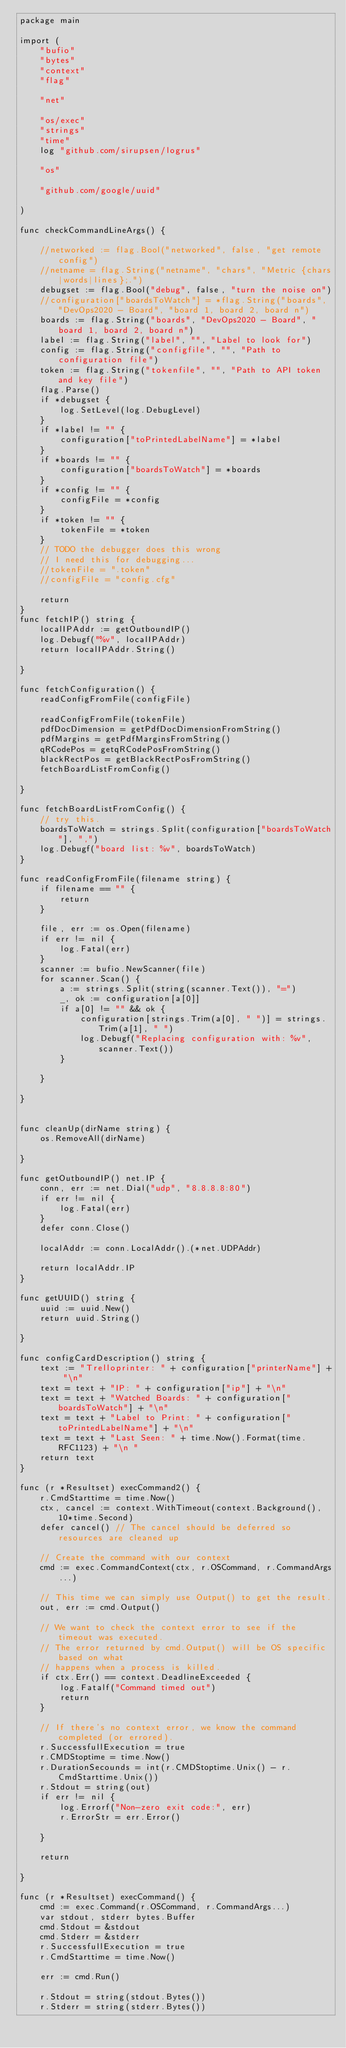<code> <loc_0><loc_0><loc_500><loc_500><_Go_>package main

import (
	"bufio"
	"bytes"
	"context"
	"flag"
	
	"net"

	"os/exec"
	"strings"
	"time"
	log "github.com/sirupsen/logrus"

	"os"

	"github.com/google/uuid"

)

func checkCommandLineArgs() {

	//networked := flag.Bool("networked", false, "get remote config")
	//netname = flag.String("netname", "chars", "Metric {chars|words|lines};.")
	debugset := flag.Bool("debug", false, "turn the noise on")
	//configuration["boardsToWatch"] = *flag.String("boards", "DevOps2020 - Board", "board 1, board 2, board n")
	boards := flag.String("boards", "DevOps2020 - Board", "board 1, board 2, board n")
	label := flag.String("label", "", "Label to look for")
	config := flag.String("configfile", "", "Path to configuration file")
	token := flag.String("tokenfile", "", "Path to API token and key file")
	flag.Parse()
	if *debugset {
		log.SetLevel(log.DebugLevel)
	}
	if *label != "" {
		configuration["toPrintedLabelName"] = *label
	}
	if *boards != "" {
		configuration["boardsToWatch"] = *boards
	}
	if *config != "" {
		configFile = *config
	}
	if *token != "" {
		tokenFile = *token
	}
	// TODO the debugger does this wrong
	// I need this for debugging...
	//tokenFile = ".token"
	//configFile = "config.cfg"

	return
}
func fetchIP() string {
	localIPAddr := getOutboundIP()
	log.Debugf("%v", localIPAddr)
	return localIPAddr.String()

}

func fetchConfiguration() {
	readConfigFromFile(configFile)

	readConfigFromFile(tokenFile)
	pdfDocDimension = getPdfDocDimensionFromString()
	pdfMargins = getPdfMarginsFromString()
	qRCodePos = getqRCodePosFromString()
	blackRectPos = getBlackRectPosFromString()
	fetchBoardListFromConfig()

}

func fetchBoardListFromConfig() {
	// try this.
	boardsToWatch = strings.Split(configuration["boardsToWatch"], ",")
	log.Debugf("board list: %v", boardsToWatch)
}

func readConfigFromFile(filename string) {
	if filename == "" {
		return
	}

	file, err := os.Open(filename)
	if err != nil {
		log.Fatal(err)
	}
	scanner := bufio.NewScanner(file)
	for scanner.Scan() {
		a := strings.Split(string(scanner.Text()), "=")
		_, ok := configuration[a[0]]
		if a[0] != "" && ok {
			configuration[strings.Trim(a[0], " ")] = strings.Trim(a[1], " ")
			log.Debugf("Replacing configuration with: %v", scanner.Text())
		}

	}

}


func cleanUp(dirName string) {
	os.RemoveAll(dirName)

}

func getOutboundIP() net.IP {
	conn, err := net.Dial("udp", "8.8.8.8:80")
	if err != nil {
		log.Fatal(err)
	}
	defer conn.Close()

	localAddr := conn.LocalAddr().(*net.UDPAddr)

	return localAddr.IP
}

func getUUID() string {
	uuid := uuid.New()
	return uuid.String()

}

func configCardDescription() string {
	text := "Trelloprinter: " + configuration["printerName"] + "\n"
	text = text + "IP: " + configuration["ip"] + "\n"
	text = text + "Watched Boards: " + configuration["boardsToWatch"] + "\n"
	text = text + "Label to Print: " + configuration["toPrintedLabelName"] + "\n"
	text = text + "Last Seen: " + time.Now().Format(time.RFC1123) + "\n "
	return text
}

func (r *Resultset) execCommand2() {
	r.CmdStarttime = time.Now()
	ctx, cancel := context.WithTimeout(context.Background(), 10*time.Second)
	defer cancel() // The cancel should be deferred so resources are cleaned up

	// Create the command with our context
	cmd := exec.CommandContext(ctx, r.OSCommand, r.CommandArgs...)

	// This time we can simply use Output() to get the result.
	out, err := cmd.Output()

	// We want to check the context error to see if the timeout was executed.
	// The error returned by cmd.Output() will be OS specific based on what
	// happens when a process is killed.
	if ctx.Err() == context.DeadlineExceeded {
		log.Fatalf("Command timed out")
		return
	}

	// If there's no context error, we know the command completed (or errored).
	r.SuccessfullExecution = true
	r.CMDStoptime = time.Now()
	r.DurationSecounds = int(r.CMDStoptime.Unix() - r.CmdStarttime.Unix())
	r.Stdout = string(out)
	if err != nil {
		log.Errorf("Non-zero exit code:", err)
		r.ErrorStr = err.Error()

	}

	return

}

func (r *Resultset) execCommand() {
	cmd := exec.Command(r.OSCommand, r.CommandArgs...)
	var stdout, stderr bytes.Buffer
	cmd.Stdout = &stdout
	cmd.Stderr = &stderr
	r.SuccessfullExecution = true
	r.CmdStarttime = time.Now()

	err := cmd.Run()

	r.Stdout = string(stdout.Bytes())
	r.Stderr = string(stderr.Bytes())</code> 